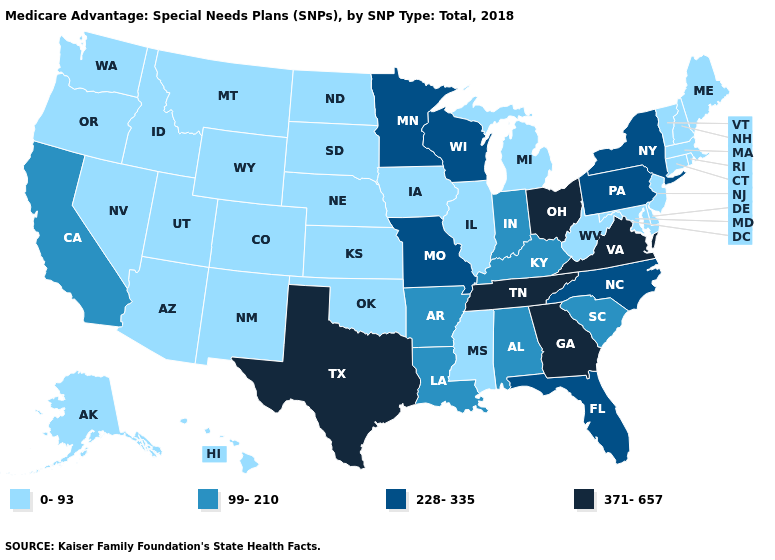Name the states that have a value in the range 0-93?
Keep it brief. Alaska, Arizona, Colorado, Connecticut, Delaware, Hawaii, Iowa, Idaho, Illinois, Kansas, Massachusetts, Maryland, Maine, Michigan, Mississippi, Montana, North Dakota, Nebraska, New Hampshire, New Jersey, New Mexico, Nevada, Oklahoma, Oregon, Rhode Island, South Dakota, Utah, Vermont, Washington, West Virginia, Wyoming. Which states have the lowest value in the Northeast?
Keep it brief. Connecticut, Massachusetts, Maine, New Hampshire, New Jersey, Rhode Island, Vermont. Name the states that have a value in the range 99-210?
Short answer required. Alabama, Arkansas, California, Indiana, Kentucky, Louisiana, South Carolina. Is the legend a continuous bar?
Quick response, please. No. Does New Mexico have the same value as North Dakota?
Short answer required. Yes. Does Illinois have a lower value than Nevada?
Keep it brief. No. What is the highest value in states that border Ohio?
Be succinct. 228-335. Name the states that have a value in the range 228-335?
Quick response, please. Florida, Minnesota, Missouri, North Carolina, New York, Pennsylvania, Wisconsin. What is the highest value in states that border Alabama?
Answer briefly. 371-657. What is the value of Tennessee?
Concise answer only. 371-657. Does Virginia have a higher value than Texas?
Answer briefly. No. What is the lowest value in the MidWest?
Quick response, please. 0-93. Does the map have missing data?
Keep it brief. No. Does South Carolina have a lower value than Louisiana?
Write a very short answer. No. What is the lowest value in states that border Georgia?
Give a very brief answer. 99-210. 